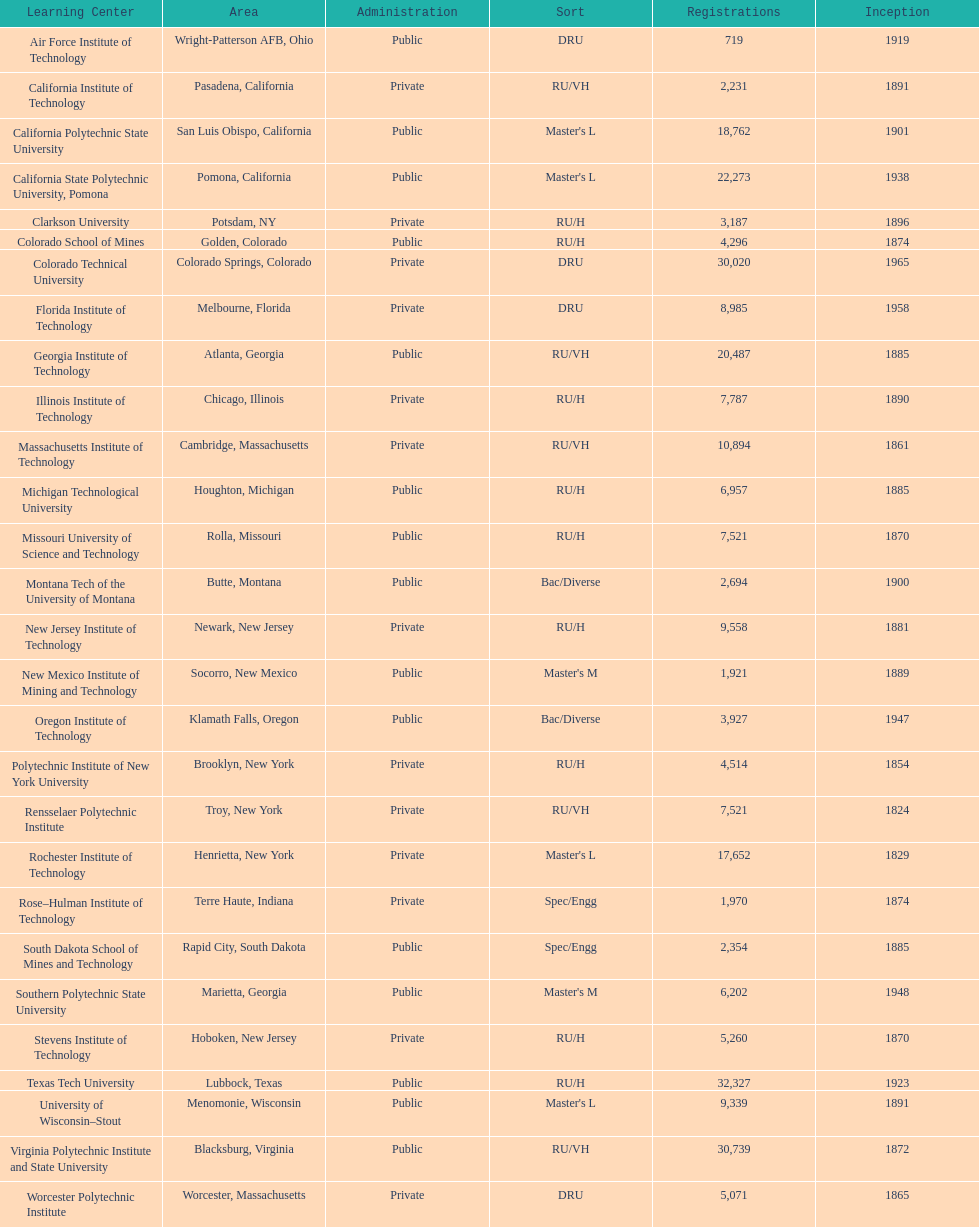Which us technological university has the top enrollment numbers? Texas Tech University. 